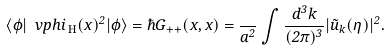Convert formula to latex. <formula><loc_0><loc_0><loc_500><loc_500>\langle \phi | \ v p h i _ { \text { H} } ( x ) ^ { 2 } | \phi \rangle = \hbar { G } _ { + + } ( x , x ) = \frac { } { a ^ { 2 } } \int \frac { d ^ { 3 } k } { ( 2 \pi ) ^ { 3 } } | \tilde { u } _ { k } ( \eta ) | ^ { 2 } .</formula> 